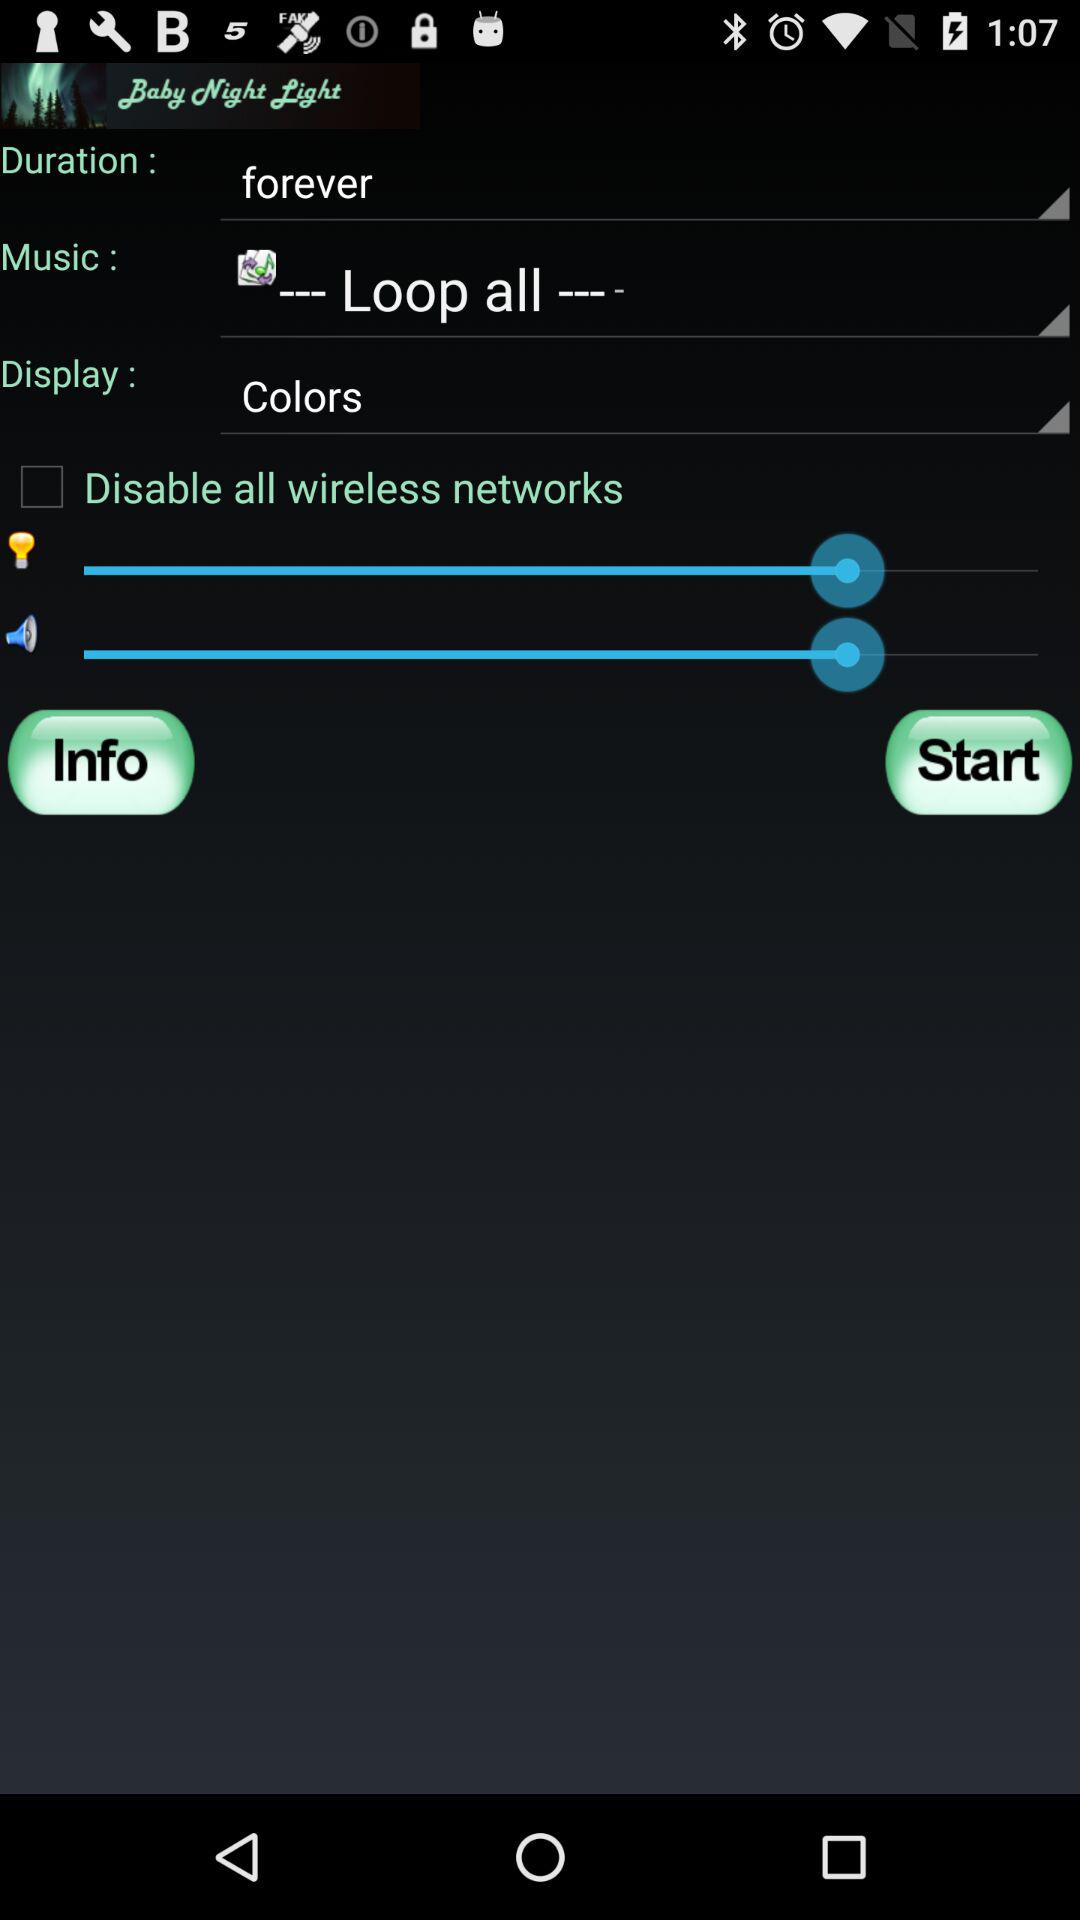What is the duration? The duration is forever. 